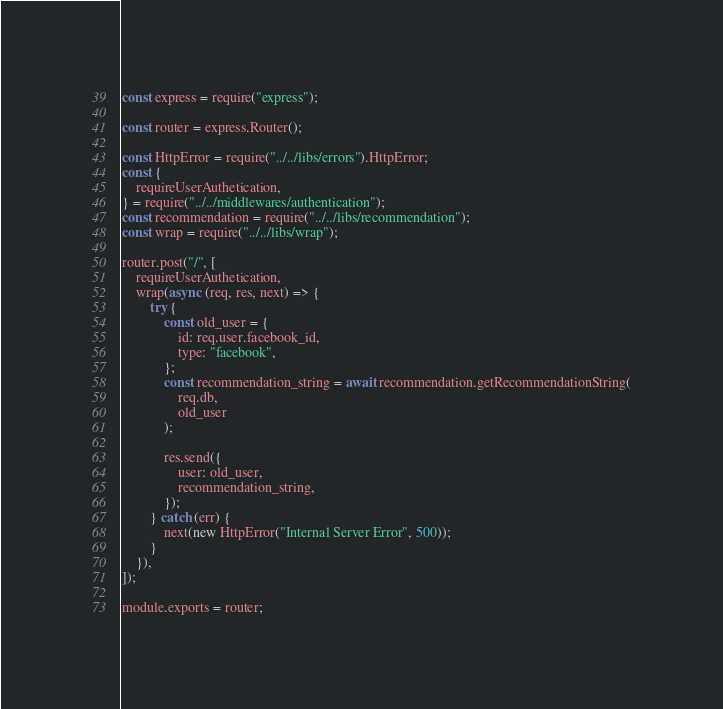<code> <loc_0><loc_0><loc_500><loc_500><_JavaScript_>const express = require("express");

const router = express.Router();

const HttpError = require("../../libs/errors").HttpError;
const {
    requireUserAuthetication,
} = require("../../middlewares/authentication");
const recommendation = require("../../libs/recommendation");
const wrap = require("../../libs/wrap");

router.post("/", [
    requireUserAuthetication,
    wrap(async (req, res, next) => {
        try {
            const old_user = {
                id: req.user.facebook_id,
                type: "facebook",
            };
            const recommendation_string = await recommendation.getRecommendationString(
                req.db,
                old_user
            );

            res.send({
                user: old_user,
                recommendation_string,
            });
        } catch (err) {
            next(new HttpError("Internal Server Error", 500));
        }
    }),
]);

module.exports = router;
</code> 